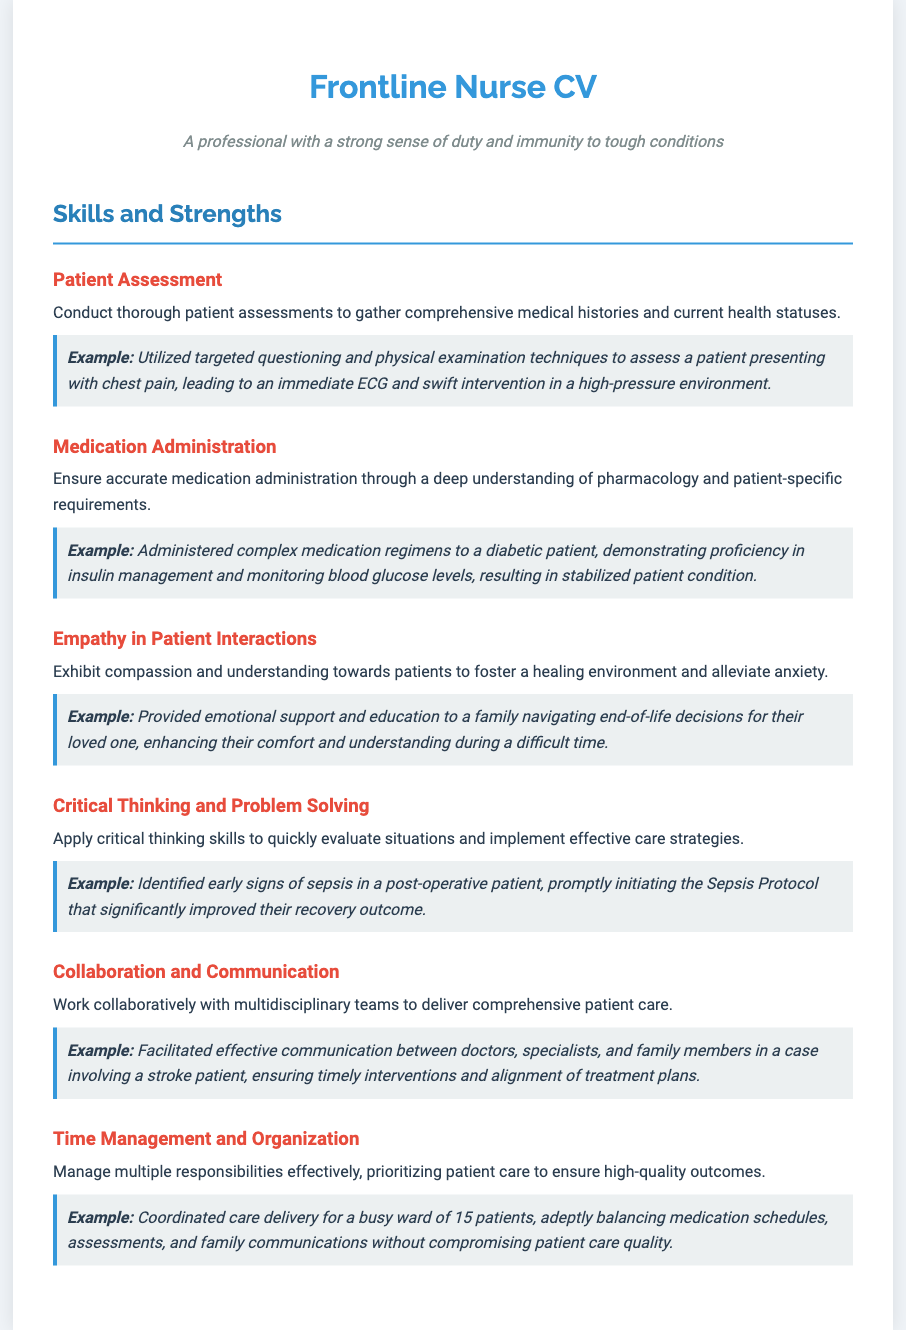What skill involves thorough patient assessments? The skill involving thorough patient assessments is explicitly mentioned under "Patient Assessment."
Answer: Patient Assessment What is the example given for medication administration? The example provided under medication administration details the administration of medication to a diabetic patient.
Answer: Administered complex medication regimens to a diabetic patient How does the document define empathy in patient interactions? The document defines empathy in patient interactions as exhibiting compassion and understanding towards patients.
Answer: Compassion and understanding What critical situation is addressed in the critical thinking skill? The critical situation addressed involves identifying early signs of sepsis in a post-operative patient.
Answer: Early signs of sepsis How many skills are listed in the document? The document lists six distinct skills in the Skills and Strengths section.
Answer: Six What role does communication play in collaboration? The document emphasizes effective communication in the context of collaboration with multidisciplinary teams.
Answer: Effective communication Which skill focuses on balancing multiple responsibilities? The skill that focuses on balancing multiple responsibilities is time management and organization.
Answer: Time Management and Organization What was the outcome of early sepsis identification? The outcome of early sepsis identification mentioned is an improvement in recovery.
Answer: Improved recovery outcome What is the primary goal of exhibiting empathy in patient interactions? The primary goal of exhibiting empathy is to foster a healing environment and alleviate anxiety.
Answer: Foster a healing environment 